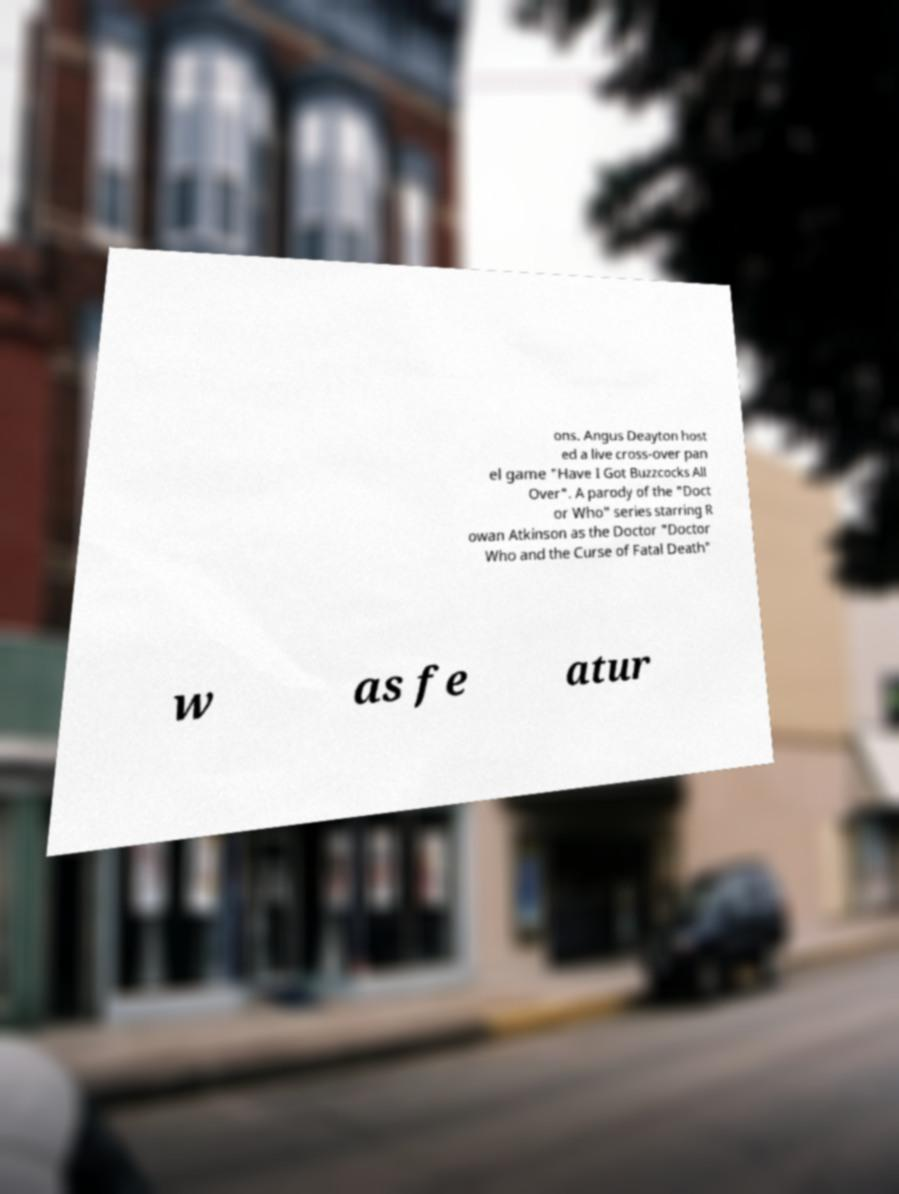There's text embedded in this image that I need extracted. Can you transcribe it verbatim? ons. Angus Deayton host ed a live cross-over pan el game "Have I Got Buzzcocks All Over". A parody of the "Doct or Who" series starring R owan Atkinson as the Doctor "Doctor Who and the Curse of Fatal Death" w as fe atur 